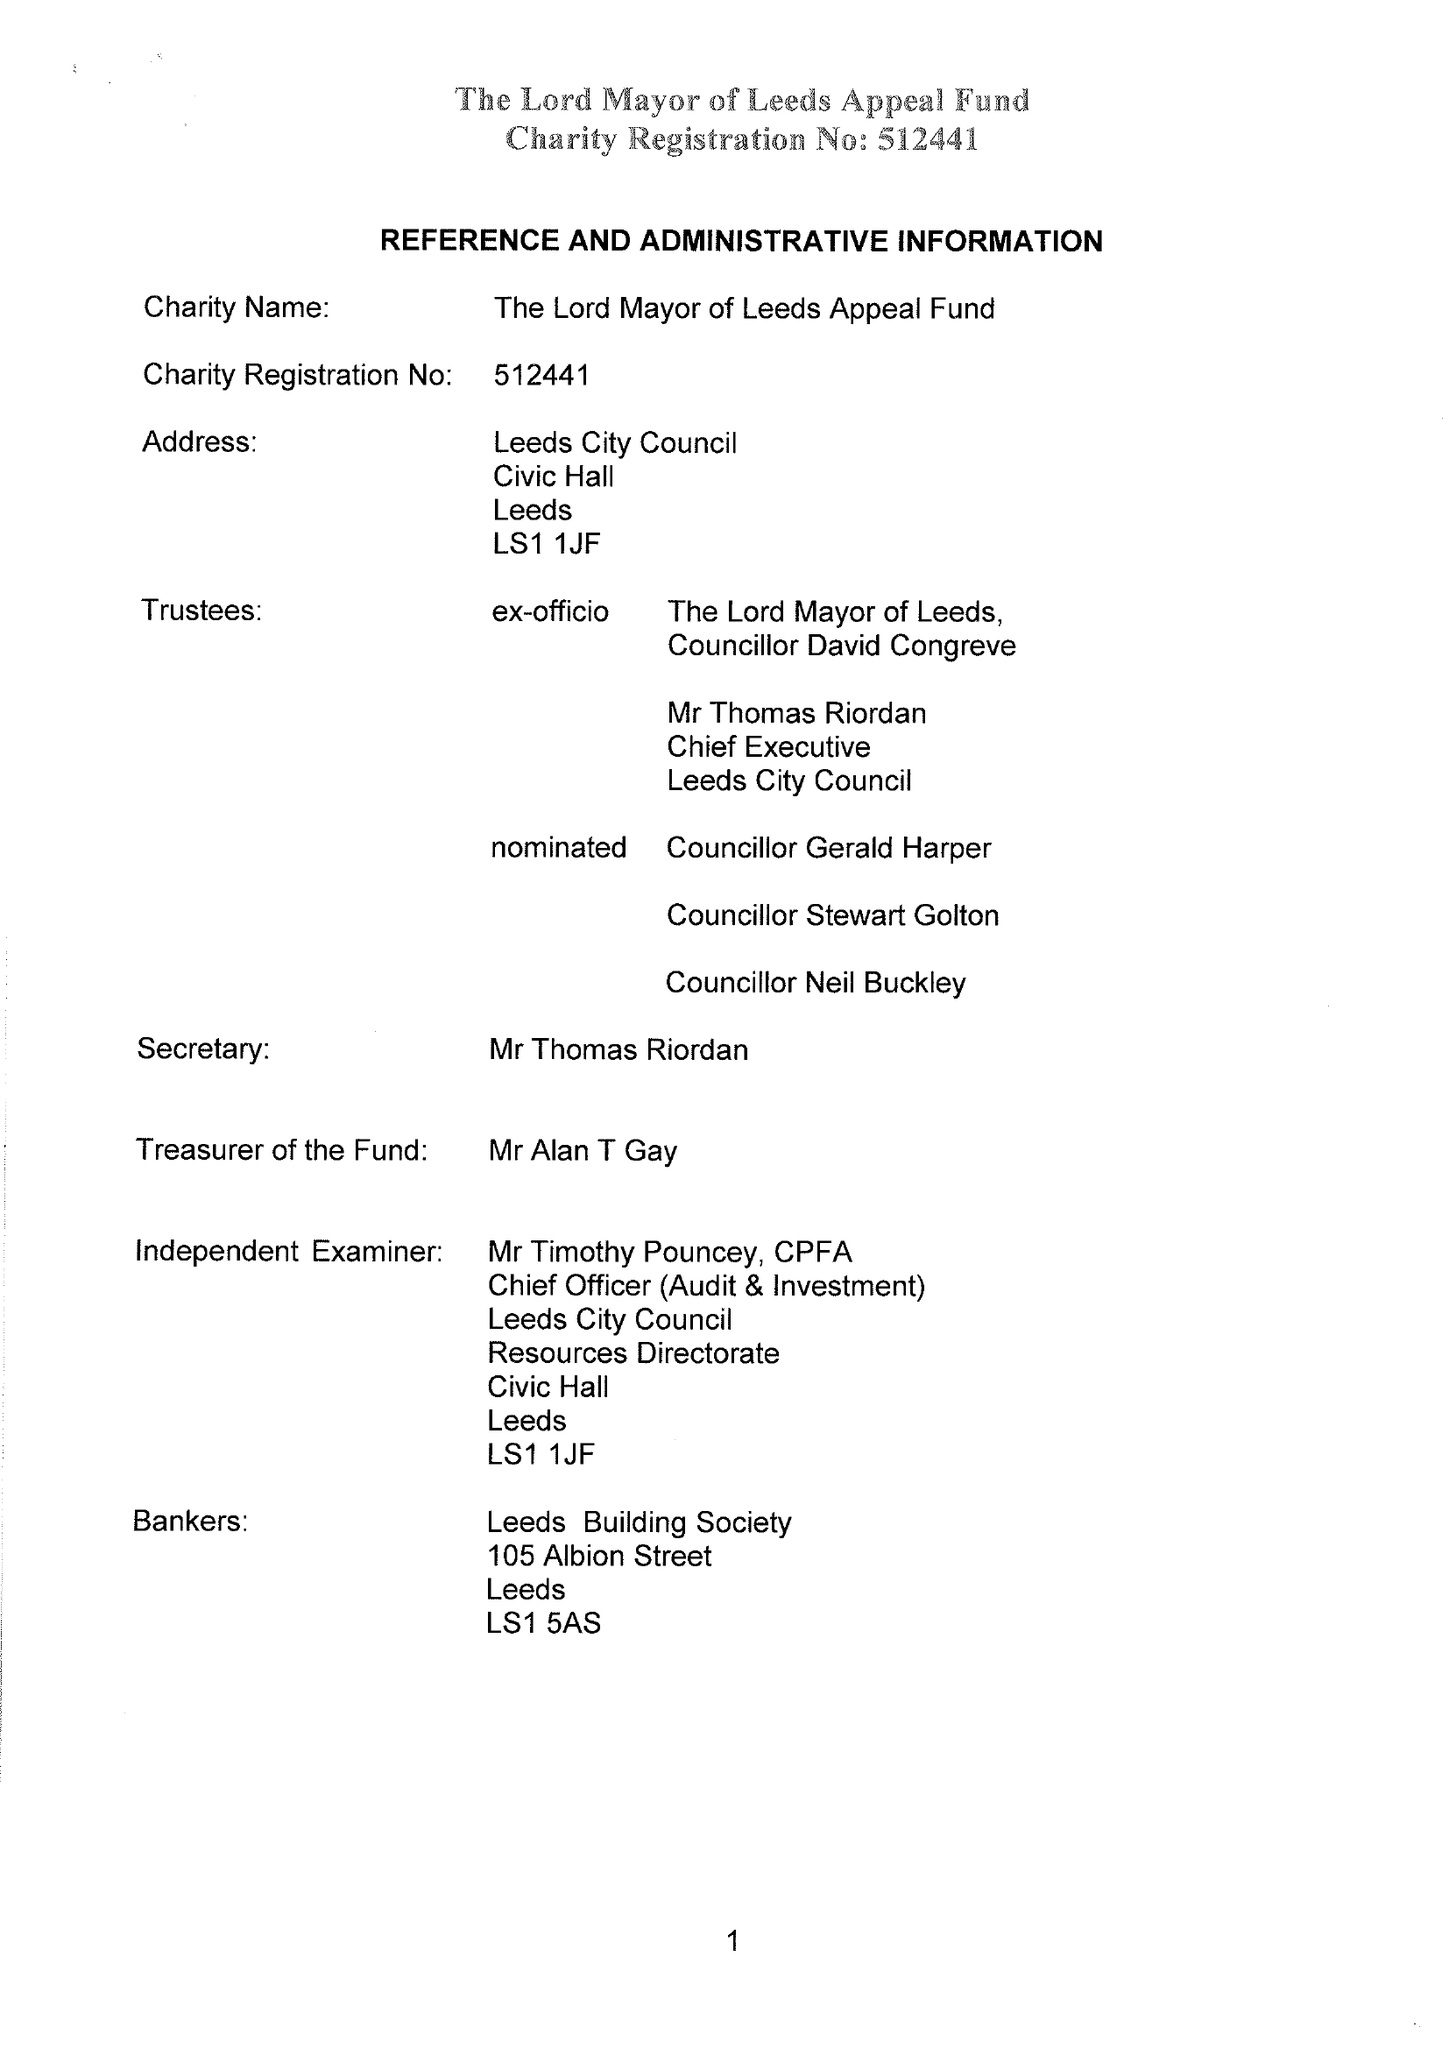What is the value for the charity_number?
Answer the question using a single word or phrase. 512441 